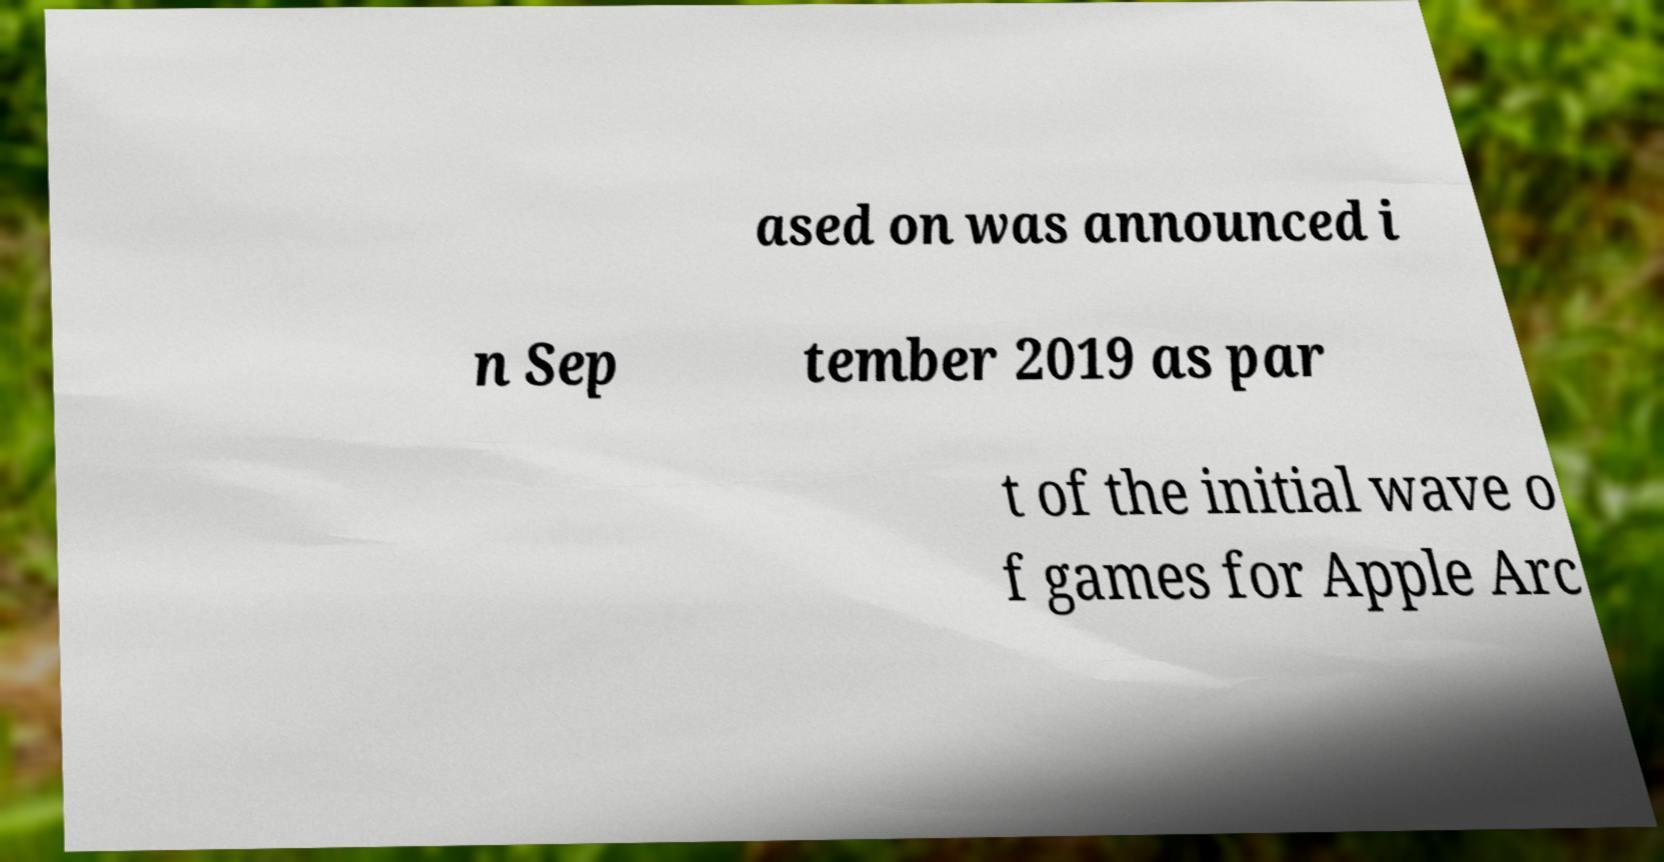Can you read and provide the text displayed in the image?This photo seems to have some interesting text. Can you extract and type it out for me? ased on was announced i n Sep tember 2019 as par t of the initial wave o f games for Apple Arc 